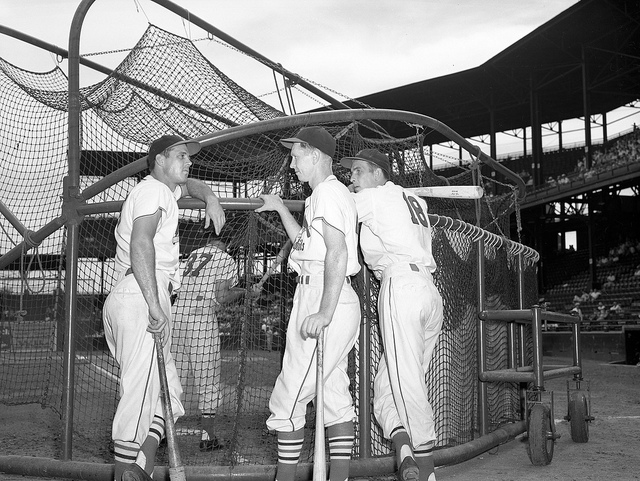<image>Where on the field are the batters standing? It is unknown where on the field the batters are standing. They might be in the dugout or batting cage. Where on the field are the batters standing? I don't know where on the field the batters are standing. It can be outside the field, in the dugout, behind the batting cage, or by the dugout. 